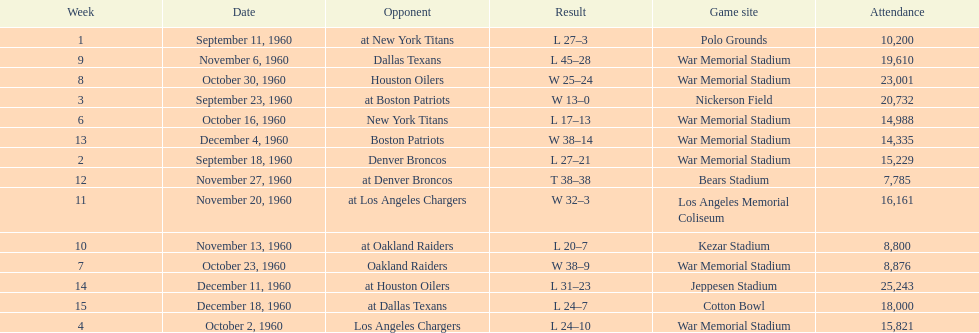The total number of games played at war memorial stadium was how many? 7. 